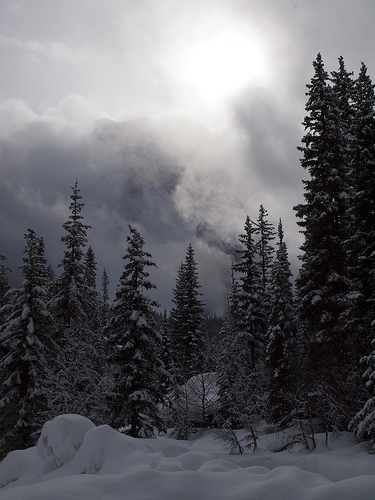<image>
Can you confirm if the sky is behind the snow? No. The sky is not behind the snow. From this viewpoint, the sky appears to be positioned elsewhere in the scene. 